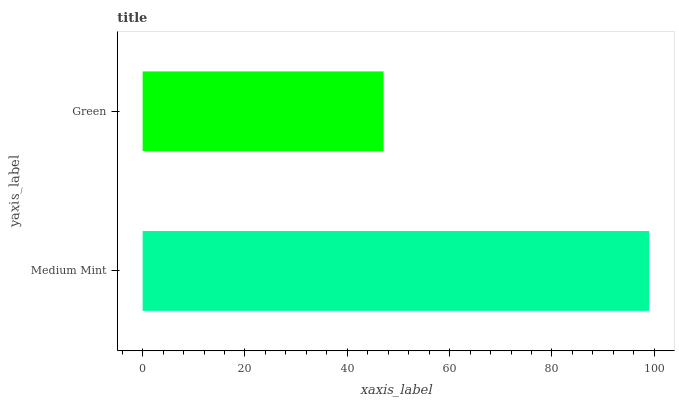Is Green the minimum?
Answer yes or no. Yes. Is Medium Mint the maximum?
Answer yes or no. Yes. Is Green the maximum?
Answer yes or no. No. Is Medium Mint greater than Green?
Answer yes or no. Yes. Is Green less than Medium Mint?
Answer yes or no. Yes. Is Green greater than Medium Mint?
Answer yes or no. No. Is Medium Mint less than Green?
Answer yes or no. No. Is Medium Mint the high median?
Answer yes or no. Yes. Is Green the low median?
Answer yes or no. Yes. Is Green the high median?
Answer yes or no. No. Is Medium Mint the low median?
Answer yes or no. No. 